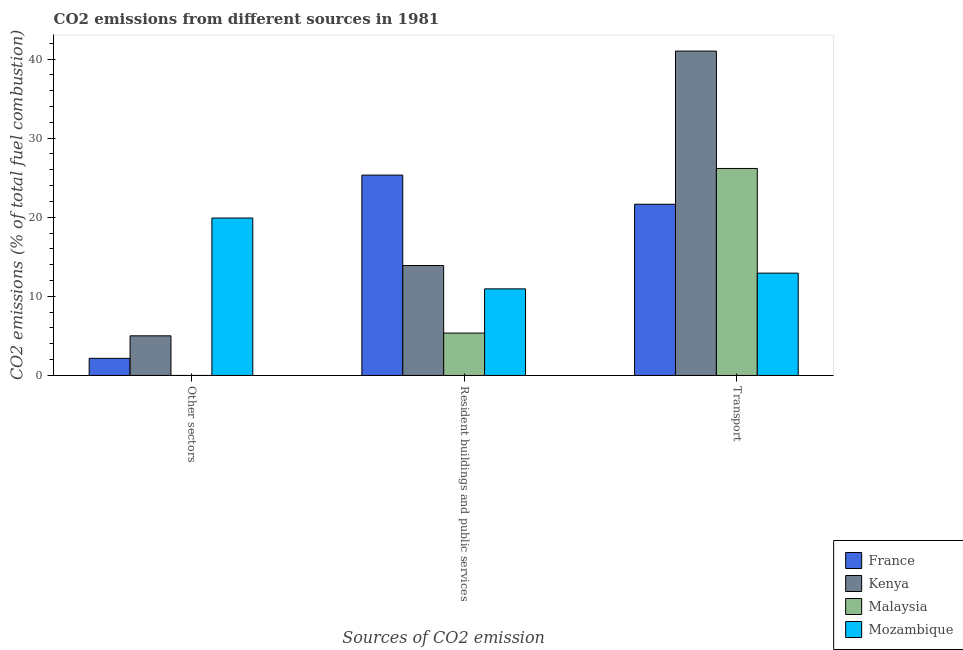How many groups of bars are there?
Provide a succinct answer. 3. Are the number of bars per tick equal to the number of legend labels?
Your answer should be compact. No. Are the number of bars on each tick of the X-axis equal?
Provide a short and direct response. No. How many bars are there on the 1st tick from the left?
Provide a short and direct response. 3. What is the label of the 3rd group of bars from the left?
Keep it short and to the point. Transport. Across all countries, what is the maximum percentage of co2 emissions from resident buildings and public services?
Provide a short and direct response. 25.33. Across all countries, what is the minimum percentage of co2 emissions from transport?
Offer a very short reply. 12.94. In which country was the percentage of co2 emissions from resident buildings and public services maximum?
Provide a short and direct response. France. What is the total percentage of co2 emissions from resident buildings and public services in the graph?
Offer a terse response. 55.52. What is the difference between the percentage of co2 emissions from transport in France and that in Mozambique?
Your answer should be compact. 8.71. What is the difference between the percentage of co2 emissions from resident buildings and public services in Kenya and the percentage of co2 emissions from transport in France?
Your answer should be compact. -7.75. What is the average percentage of co2 emissions from other sectors per country?
Make the answer very short. 6.77. What is the difference between the percentage of co2 emissions from other sectors and percentage of co2 emissions from transport in Kenya?
Give a very brief answer. -35.99. In how many countries, is the percentage of co2 emissions from transport greater than 38 %?
Make the answer very short. 1. What is the ratio of the percentage of co2 emissions from resident buildings and public services in Kenya to that in Mozambique?
Your response must be concise. 1.27. What is the difference between the highest and the second highest percentage of co2 emissions from other sectors?
Make the answer very short. 14.89. What is the difference between the highest and the lowest percentage of co2 emissions from transport?
Ensure brevity in your answer.  28.07. In how many countries, is the percentage of co2 emissions from other sectors greater than the average percentage of co2 emissions from other sectors taken over all countries?
Your response must be concise. 1. Is the sum of the percentage of co2 emissions from resident buildings and public services in France and Kenya greater than the maximum percentage of co2 emissions from transport across all countries?
Your response must be concise. No. How many bars are there?
Ensure brevity in your answer.  11. How many countries are there in the graph?
Ensure brevity in your answer.  4. Are the values on the major ticks of Y-axis written in scientific E-notation?
Your answer should be compact. No. Does the graph contain grids?
Your response must be concise. No. How many legend labels are there?
Give a very brief answer. 4. How are the legend labels stacked?
Your answer should be compact. Vertical. What is the title of the graph?
Your response must be concise. CO2 emissions from different sources in 1981. What is the label or title of the X-axis?
Make the answer very short. Sources of CO2 emission. What is the label or title of the Y-axis?
Offer a very short reply. CO2 emissions (% of total fuel combustion). What is the CO2 emissions (% of total fuel combustion) of France in Other sectors?
Give a very brief answer. 2.16. What is the CO2 emissions (% of total fuel combustion) of Kenya in Other sectors?
Make the answer very short. 5.01. What is the CO2 emissions (% of total fuel combustion) in Mozambique in Other sectors?
Ensure brevity in your answer.  19.9. What is the CO2 emissions (% of total fuel combustion) of France in Resident buildings and public services?
Make the answer very short. 25.33. What is the CO2 emissions (% of total fuel combustion) of Kenya in Resident buildings and public services?
Ensure brevity in your answer.  13.9. What is the CO2 emissions (% of total fuel combustion) of Malaysia in Resident buildings and public services?
Ensure brevity in your answer.  5.36. What is the CO2 emissions (% of total fuel combustion) in Mozambique in Resident buildings and public services?
Your answer should be very brief. 10.95. What is the CO2 emissions (% of total fuel combustion) of France in Transport?
Your answer should be very brief. 21.64. What is the CO2 emissions (% of total fuel combustion) in Kenya in Transport?
Provide a short and direct response. 41. What is the CO2 emissions (% of total fuel combustion) of Malaysia in Transport?
Your answer should be compact. 26.17. What is the CO2 emissions (% of total fuel combustion) in Mozambique in Transport?
Your response must be concise. 12.94. Across all Sources of CO2 emission, what is the maximum CO2 emissions (% of total fuel combustion) in France?
Provide a succinct answer. 25.33. Across all Sources of CO2 emission, what is the maximum CO2 emissions (% of total fuel combustion) in Kenya?
Your answer should be compact. 41. Across all Sources of CO2 emission, what is the maximum CO2 emissions (% of total fuel combustion) in Malaysia?
Your response must be concise. 26.17. Across all Sources of CO2 emission, what is the maximum CO2 emissions (% of total fuel combustion) of Mozambique?
Your answer should be compact. 19.9. Across all Sources of CO2 emission, what is the minimum CO2 emissions (% of total fuel combustion) of France?
Offer a very short reply. 2.16. Across all Sources of CO2 emission, what is the minimum CO2 emissions (% of total fuel combustion) in Kenya?
Provide a short and direct response. 5.01. Across all Sources of CO2 emission, what is the minimum CO2 emissions (% of total fuel combustion) of Mozambique?
Your answer should be very brief. 10.95. What is the total CO2 emissions (% of total fuel combustion) of France in the graph?
Provide a short and direct response. 49.13. What is the total CO2 emissions (% of total fuel combustion) of Kenya in the graph?
Your answer should be compact. 59.91. What is the total CO2 emissions (% of total fuel combustion) of Malaysia in the graph?
Make the answer very short. 31.52. What is the total CO2 emissions (% of total fuel combustion) of Mozambique in the graph?
Keep it short and to the point. 43.78. What is the difference between the CO2 emissions (% of total fuel combustion) in France in Other sectors and that in Resident buildings and public services?
Provide a short and direct response. -23.16. What is the difference between the CO2 emissions (% of total fuel combustion) in Kenya in Other sectors and that in Resident buildings and public services?
Provide a short and direct response. -8.88. What is the difference between the CO2 emissions (% of total fuel combustion) of Mozambique in Other sectors and that in Resident buildings and public services?
Ensure brevity in your answer.  8.96. What is the difference between the CO2 emissions (% of total fuel combustion) of France in Other sectors and that in Transport?
Make the answer very short. -19.48. What is the difference between the CO2 emissions (% of total fuel combustion) of Kenya in Other sectors and that in Transport?
Offer a very short reply. -35.99. What is the difference between the CO2 emissions (% of total fuel combustion) of Mozambique in Other sectors and that in Transport?
Provide a short and direct response. 6.97. What is the difference between the CO2 emissions (% of total fuel combustion) of France in Resident buildings and public services and that in Transport?
Ensure brevity in your answer.  3.68. What is the difference between the CO2 emissions (% of total fuel combustion) of Kenya in Resident buildings and public services and that in Transport?
Offer a terse response. -27.11. What is the difference between the CO2 emissions (% of total fuel combustion) in Malaysia in Resident buildings and public services and that in Transport?
Your answer should be very brief. -20.81. What is the difference between the CO2 emissions (% of total fuel combustion) of Mozambique in Resident buildings and public services and that in Transport?
Your answer should be compact. -1.99. What is the difference between the CO2 emissions (% of total fuel combustion) of France in Other sectors and the CO2 emissions (% of total fuel combustion) of Kenya in Resident buildings and public services?
Keep it short and to the point. -11.73. What is the difference between the CO2 emissions (% of total fuel combustion) of France in Other sectors and the CO2 emissions (% of total fuel combustion) of Malaysia in Resident buildings and public services?
Your answer should be very brief. -3.19. What is the difference between the CO2 emissions (% of total fuel combustion) of France in Other sectors and the CO2 emissions (% of total fuel combustion) of Mozambique in Resident buildings and public services?
Provide a short and direct response. -8.78. What is the difference between the CO2 emissions (% of total fuel combustion) of Kenya in Other sectors and the CO2 emissions (% of total fuel combustion) of Malaysia in Resident buildings and public services?
Your answer should be very brief. -0.35. What is the difference between the CO2 emissions (% of total fuel combustion) of Kenya in Other sectors and the CO2 emissions (% of total fuel combustion) of Mozambique in Resident buildings and public services?
Provide a succinct answer. -5.93. What is the difference between the CO2 emissions (% of total fuel combustion) of France in Other sectors and the CO2 emissions (% of total fuel combustion) of Kenya in Transport?
Your answer should be very brief. -38.84. What is the difference between the CO2 emissions (% of total fuel combustion) of France in Other sectors and the CO2 emissions (% of total fuel combustion) of Malaysia in Transport?
Make the answer very short. -24. What is the difference between the CO2 emissions (% of total fuel combustion) of France in Other sectors and the CO2 emissions (% of total fuel combustion) of Mozambique in Transport?
Offer a terse response. -10.77. What is the difference between the CO2 emissions (% of total fuel combustion) in Kenya in Other sectors and the CO2 emissions (% of total fuel combustion) in Malaysia in Transport?
Make the answer very short. -21.15. What is the difference between the CO2 emissions (% of total fuel combustion) of Kenya in Other sectors and the CO2 emissions (% of total fuel combustion) of Mozambique in Transport?
Give a very brief answer. -7.92. What is the difference between the CO2 emissions (% of total fuel combustion) in France in Resident buildings and public services and the CO2 emissions (% of total fuel combustion) in Kenya in Transport?
Keep it short and to the point. -15.68. What is the difference between the CO2 emissions (% of total fuel combustion) of France in Resident buildings and public services and the CO2 emissions (% of total fuel combustion) of Malaysia in Transport?
Make the answer very short. -0.84. What is the difference between the CO2 emissions (% of total fuel combustion) in France in Resident buildings and public services and the CO2 emissions (% of total fuel combustion) in Mozambique in Transport?
Make the answer very short. 12.39. What is the difference between the CO2 emissions (% of total fuel combustion) in Kenya in Resident buildings and public services and the CO2 emissions (% of total fuel combustion) in Malaysia in Transport?
Make the answer very short. -12.27. What is the difference between the CO2 emissions (% of total fuel combustion) of Kenya in Resident buildings and public services and the CO2 emissions (% of total fuel combustion) of Mozambique in Transport?
Provide a succinct answer. 0.96. What is the difference between the CO2 emissions (% of total fuel combustion) in Malaysia in Resident buildings and public services and the CO2 emissions (% of total fuel combustion) in Mozambique in Transport?
Provide a short and direct response. -7.58. What is the average CO2 emissions (% of total fuel combustion) in France per Sources of CO2 emission?
Provide a short and direct response. 16.38. What is the average CO2 emissions (% of total fuel combustion) in Kenya per Sources of CO2 emission?
Give a very brief answer. 19.97. What is the average CO2 emissions (% of total fuel combustion) of Malaysia per Sources of CO2 emission?
Offer a terse response. 10.51. What is the average CO2 emissions (% of total fuel combustion) in Mozambique per Sources of CO2 emission?
Your answer should be compact. 14.59. What is the difference between the CO2 emissions (% of total fuel combustion) in France and CO2 emissions (% of total fuel combustion) in Kenya in Other sectors?
Your answer should be compact. -2.85. What is the difference between the CO2 emissions (% of total fuel combustion) of France and CO2 emissions (% of total fuel combustion) of Mozambique in Other sectors?
Make the answer very short. -17.74. What is the difference between the CO2 emissions (% of total fuel combustion) in Kenya and CO2 emissions (% of total fuel combustion) in Mozambique in Other sectors?
Your answer should be very brief. -14.89. What is the difference between the CO2 emissions (% of total fuel combustion) in France and CO2 emissions (% of total fuel combustion) in Kenya in Resident buildings and public services?
Provide a short and direct response. 11.43. What is the difference between the CO2 emissions (% of total fuel combustion) of France and CO2 emissions (% of total fuel combustion) of Malaysia in Resident buildings and public services?
Provide a succinct answer. 19.97. What is the difference between the CO2 emissions (% of total fuel combustion) of France and CO2 emissions (% of total fuel combustion) of Mozambique in Resident buildings and public services?
Provide a succinct answer. 14.38. What is the difference between the CO2 emissions (% of total fuel combustion) in Kenya and CO2 emissions (% of total fuel combustion) in Malaysia in Resident buildings and public services?
Keep it short and to the point. 8.54. What is the difference between the CO2 emissions (% of total fuel combustion) of Kenya and CO2 emissions (% of total fuel combustion) of Mozambique in Resident buildings and public services?
Make the answer very short. 2.95. What is the difference between the CO2 emissions (% of total fuel combustion) of Malaysia and CO2 emissions (% of total fuel combustion) of Mozambique in Resident buildings and public services?
Provide a short and direct response. -5.59. What is the difference between the CO2 emissions (% of total fuel combustion) of France and CO2 emissions (% of total fuel combustion) of Kenya in Transport?
Make the answer very short. -19.36. What is the difference between the CO2 emissions (% of total fuel combustion) of France and CO2 emissions (% of total fuel combustion) of Malaysia in Transport?
Ensure brevity in your answer.  -4.52. What is the difference between the CO2 emissions (% of total fuel combustion) of France and CO2 emissions (% of total fuel combustion) of Mozambique in Transport?
Your response must be concise. 8.71. What is the difference between the CO2 emissions (% of total fuel combustion) of Kenya and CO2 emissions (% of total fuel combustion) of Malaysia in Transport?
Keep it short and to the point. 14.84. What is the difference between the CO2 emissions (% of total fuel combustion) in Kenya and CO2 emissions (% of total fuel combustion) in Mozambique in Transport?
Your answer should be very brief. 28.07. What is the difference between the CO2 emissions (% of total fuel combustion) of Malaysia and CO2 emissions (% of total fuel combustion) of Mozambique in Transport?
Provide a short and direct response. 13.23. What is the ratio of the CO2 emissions (% of total fuel combustion) of France in Other sectors to that in Resident buildings and public services?
Provide a short and direct response. 0.09. What is the ratio of the CO2 emissions (% of total fuel combustion) in Kenya in Other sectors to that in Resident buildings and public services?
Make the answer very short. 0.36. What is the ratio of the CO2 emissions (% of total fuel combustion) in Mozambique in Other sectors to that in Resident buildings and public services?
Offer a terse response. 1.82. What is the ratio of the CO2 emissions (% of total fuel combustion) of Kenya in Other sectors to that in Transport?
Provide a short and direct response. 0.12. What is the ratio of the CO2 emissions (% of total fuel combustion) in Mozambique in Other sectors to that in Transport?
Your answer should be very brief. 1.54. What is the ratio of the CO2 emissions (% of total fuel combustion) in France in Resident buildings and public services to that in Transport?
Provide a short and direct response. 1.17. What is the ratio of the CO2 emissions (% of total fuel combustion) in Kenya in Resident buildings and public services to that in Transport?
Ensure brevity in your answer.  0.34. What is the ratio of the CO2 emissions (% of total fuel combustion) of Malaysia in Resident buildings and public services to that in Transport?
Ensure brevity in your answer.  0.2. What is the ratio of the CO2 emissions (% of total fuel combustion) of Mozambique in Resident buildings and public services to that in Transport?
Offer a terse response. 0.85. What is the difference between the highest and the second highest CO2 emissions (% of total fuel combustion) of France?
Make the answer very short. 3.68. What is the difference between the highest and the second highest CO2 emissions (% of total fuel combustion) in Kenya?
Provide a succinct answer. 27.11. What is the difference between the highest and the second highest CO2 emissions (% of total fuel combustion) in Mozambique?
Your answer should be very brief. 6.97. What is the difference between the highest and the lowest CO2 emissions (% of total fuel combustion) of France?
Offer a very short reply. 23.16. What is the difference between the highest and the lowest CO2 emissions (% of total fuel combustion) of Kenya?
Offer a very short reply. 35.99. What is the difference between the highest and the lowest CO2 emissions (% of total fuel combustion) in Malaysia?
Your answer should be very brief. 26.17. What is the difference between the highest and the lowest CO2 emissions (% of total fuel combustion) of Mozambique?
Your answer should be very brief. 8.96. 